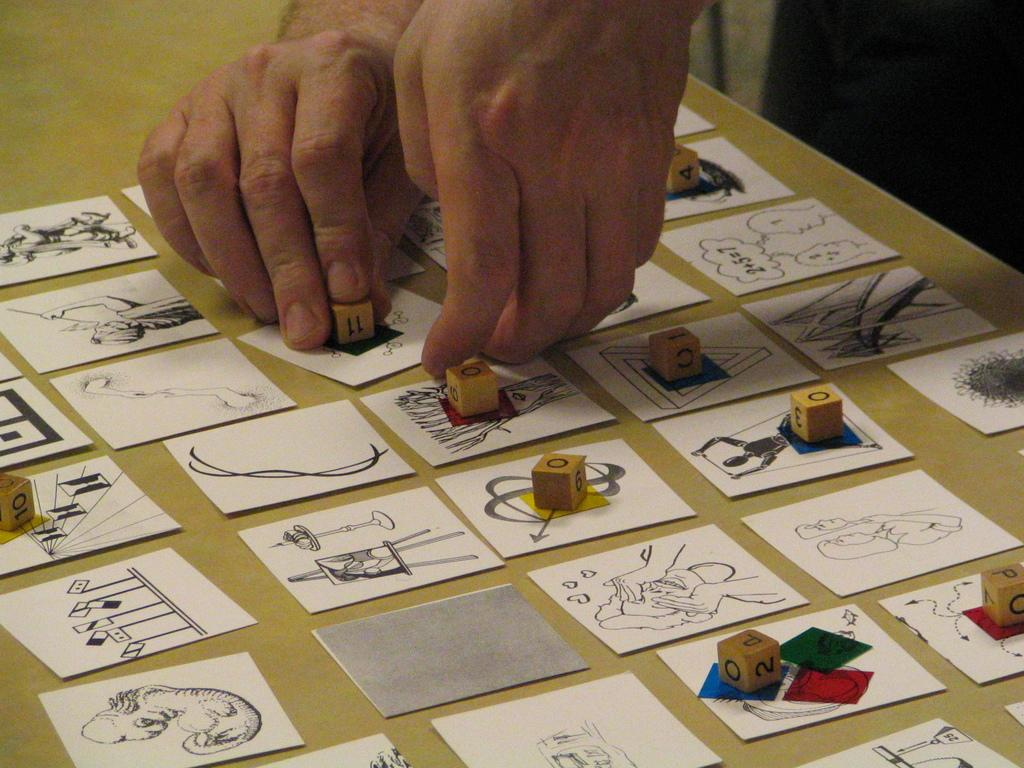What is on the platform in the image? There are stickers on a platform in the image. Are there any additional elements on the stickers? Yes, there are pieces on some of the stickers. What is the person's hand holding in the image? The person's hand is holding a dice. Where is the dice placed in the image? The dice is on a sticker on the platform. What type of support can be seen holding up the stickers in the image? There is no visible support holding up the stickers in the image; they appear to be adhered directly to the platform. 